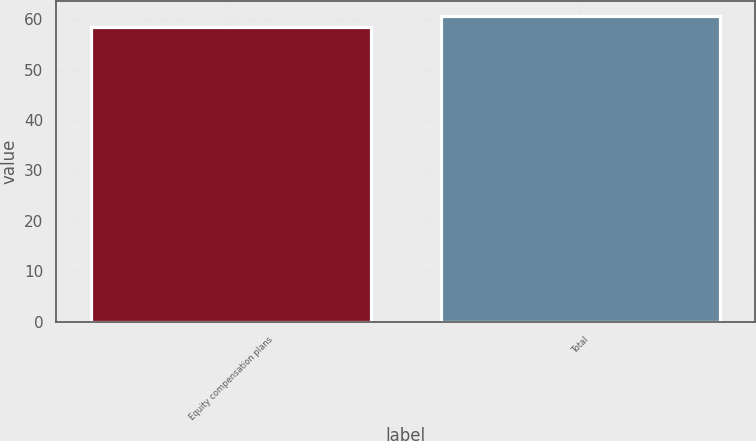<chart> <loc_0><loc_0><loc_500><loc_500><bar_chart><fcel>Equity compensation plans<fcel>Total<nl><fcel>58.35<fcel>60.57<nl></chart> 